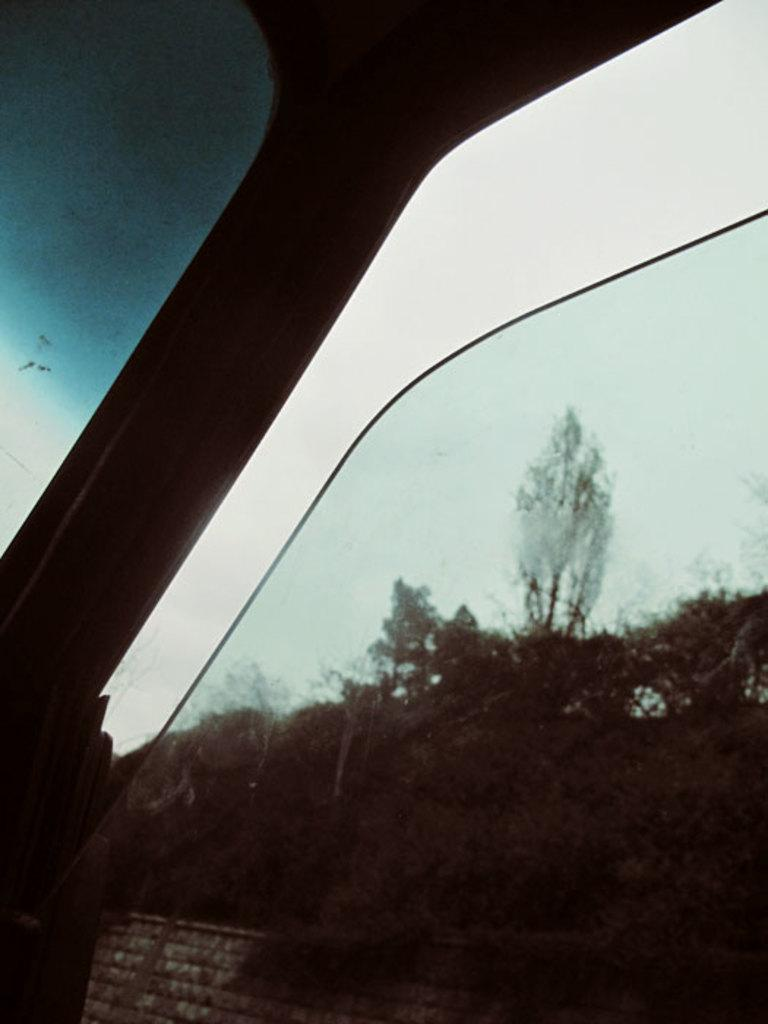What type of structure is present in the image? There is a glass window in the image. What is the state of the glass window? The glass window is partially open. What can be seen through the glass window? Trees, a wall, and the sky are visible through the glass window. What type of pot is visible in the mouth of the person in the image? There is no person or pot present in the image; it features a glass window with a view of trees, a wall, and the sky. 